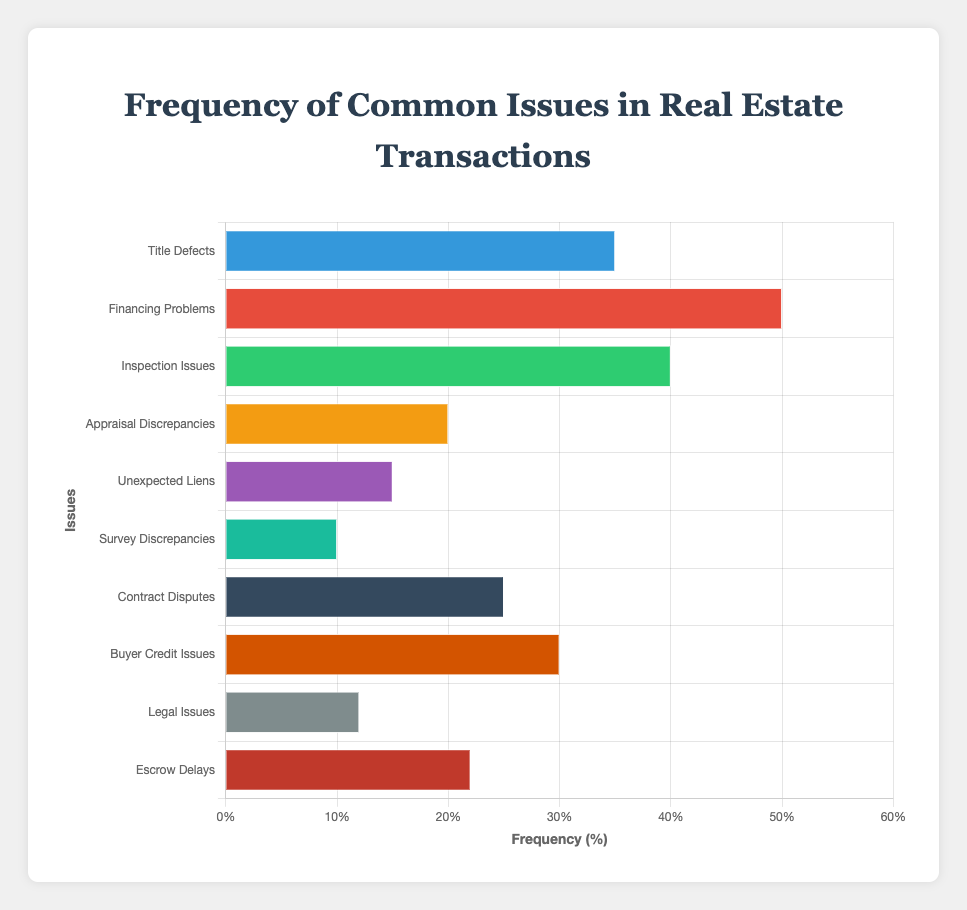Which issue has the highest frequency? To determine the issue with the highest frequency, look for the longest bar in the chart. The "Financing Problems" bar is the longest.
Answer: Financing Problems Which issue occurs more frequently: Title Defects or Inspection Issues? Compare the lengths of the bars for "Title Defects" and "Inspection Issues." The "Inspection Issues" bar is longer than the "Title Defects" bar.
Answer: Inspection Issues What is the total frequency of Appraisal Discrepancies and Unexpected Liens combined? Add the frequencies of "Appraisal Discrepancies" (20) and "Unexpected Liens" (15). The sum is 20 + 15 = 35.
Answer: 35 Which issue has a lower frequency: Legal Issues or Escrow Delays? Compare the lengths of the bars for "Legal Issues" and "Escrow Delays." The "Legal Issues" bar is shorter than the "Escrow Delays" bar.
Answer: Legal Issues What is the average frequency of Buyer Credit Issues, Contract Disputes, and Survey Discrepancies? Calculate the sum of the frequencies of "Buyer Credit Issues" (30), "Contract Disputes" (25), and "Survey Discrepancies" (10). The sum is 30 + 25 + 10 = 65. Then, divide by 3 to get the average: 65 / 3 ≈ 21.67.
Answer: 21.67 Is the frequency of Inspection Issues greater than the frequency of Appraisal Discrepancies and Unexpected Liens combined? The frequency of "Inspection Issues" is 40. The combined frequency of "Appraisal Discrepancies" and "Unexpected Liens" is 20 + 15 = 35. Since 40 > 35, "Inspection Issues" has a higher frequency.
Answer: Yes What is the frequency difference between Financing Problems and Survey Discrepancies? Subtract the frequency of "Survey Discrepancies" (10) from "Financing Problems" (50). The difference is 50 - 10 = 40.
Answer: 40 How does the frequency of Contract Disputes compare to Legal Issues? Compare the frequencies of "Contract Disputes" (25) and "Legal Issues" (12). Since 25 > 12, "Contract Disputes" occurs more frequently.
Answer: More frequent 